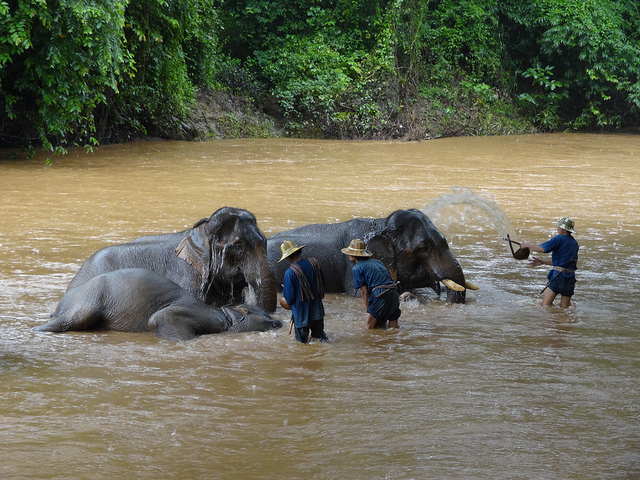<image>Are these elephants sad? I don't know if the elephants are sad or not. Are these elephants sad? I am not sure if these elephants are sad. Some of them may be sad, but some of them may not be. 